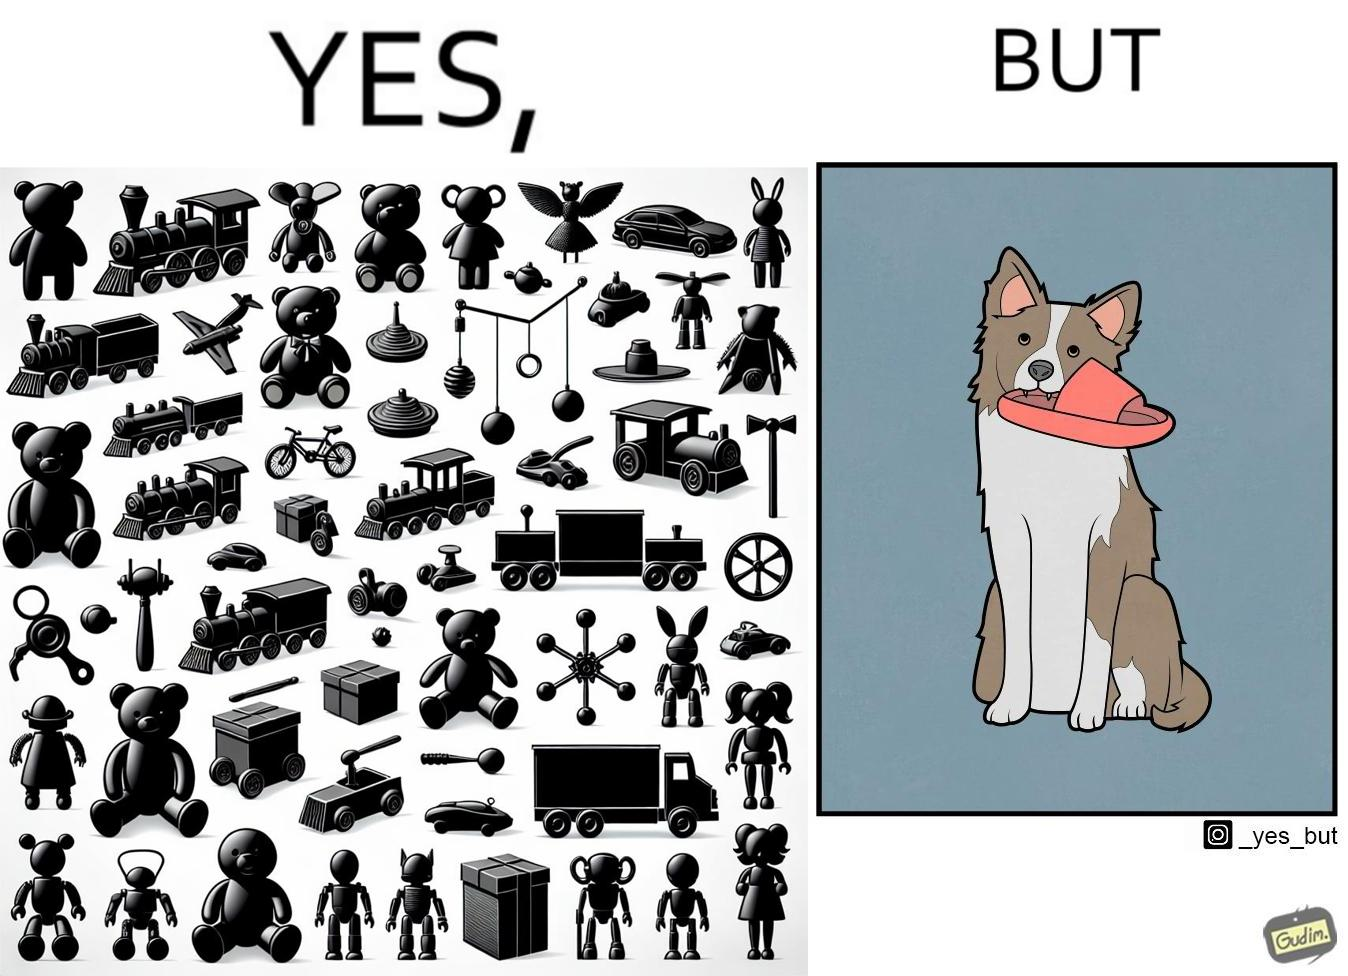What do you see in each half of this image? In the left part of the image: a bunch of toys. In the right part of the image: a dog holding a slipper in its mouth. 